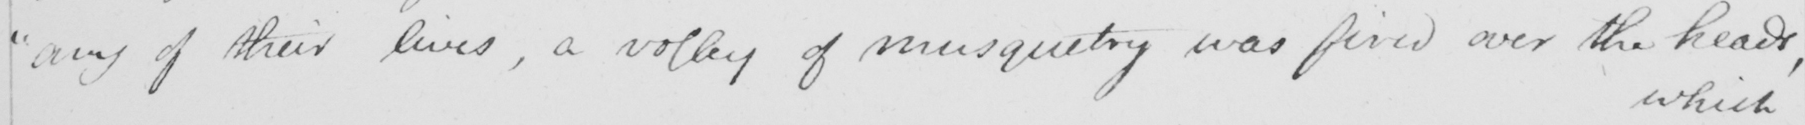Can you read and transcribe this handwriting? " any of their lives , a volley of musketry was fired over the heads , 